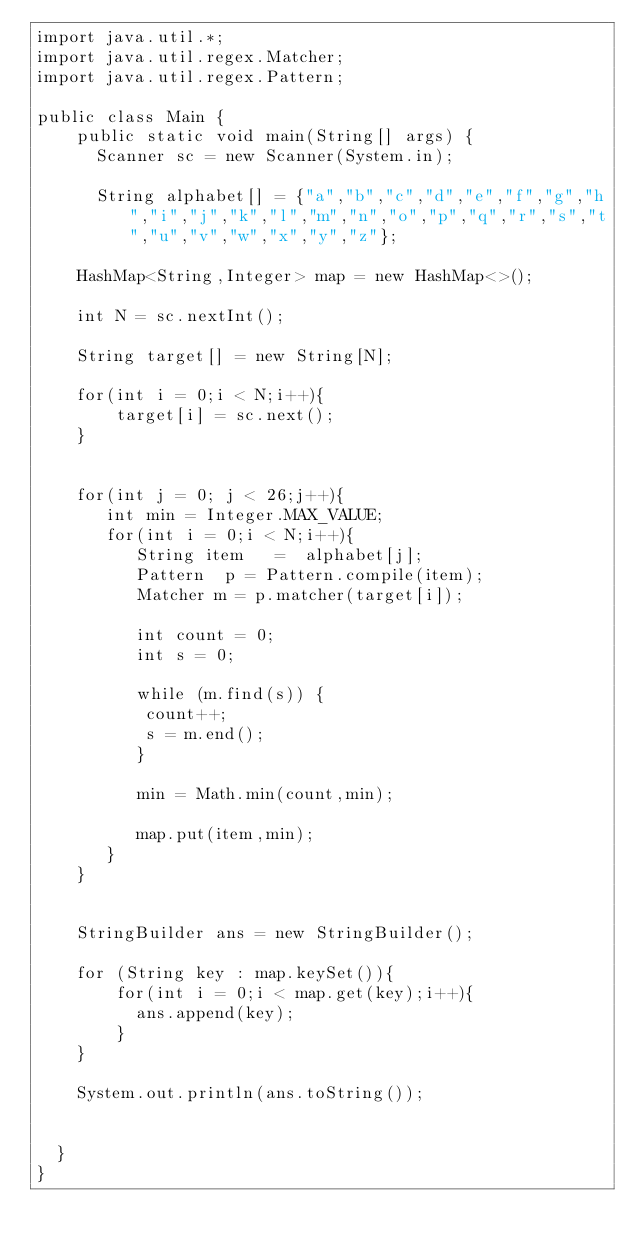<code> <loc_0><loc_0><loc_500><loc_500><_Java_>import java.util.*;
import java.util.regex.Matcher;
import java.util.regex.Pattern;

public class Main {           
    public static void main(String[] args) {		        
      Scanner sc = new Scanner(System.in);                                       
         
      String alphabet[] = {"a","b","c","d","e","f","g","h","i","j","k","l","m","n","o","p","q","r","s","t","u","v","w","x","y","z"};         
    
    HashMap<String,Integer> map = new HashMap<>();                            

    int N = sc.nextInt();
    
    String target[] = new String[N];
    
    for(int i = 0;i < N;i++){
        target[i] = sc.next();
    }
    
    
    for(int j = 0; j < 26;j++){          
       int min = Integer.MAX_VALUE;
       for(int i = 0;i < N;i++){                 
          String item   =  alphabet[j];         
          Pattern  p = Pattern.compile(item);
          Matcher m = p.matcher(target[i]);         

          int count = 0;
          int s = 0;                  
          
          while (m.find(s)) {
           count++;
           s = m.end();
          }         
          
          min = Math.min(count,min);
          
          map.put(item,min);                                      
       }            
    }        
    
        
    StringBuilder ans = new StringBuilder();    
    
    for (String key : map.keySet()){        
        for(int i = 0;i < map.get(key);i++){
          ans.append(key);
        }          
    }  

    System.out.println(ans.toString());

    
  }
}
        
        
        
        
        </code> 